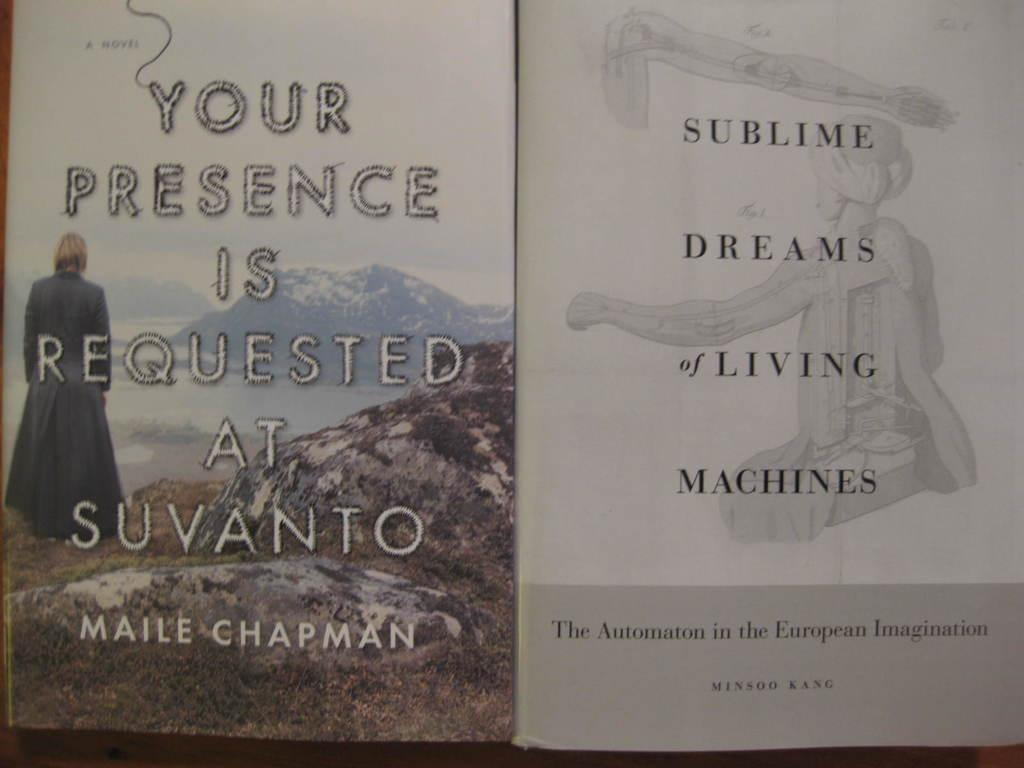<image>
Offer a succinct explanation of the picture presented. A man looking towards the mountains in on the cover a book by Maile Chapman. 